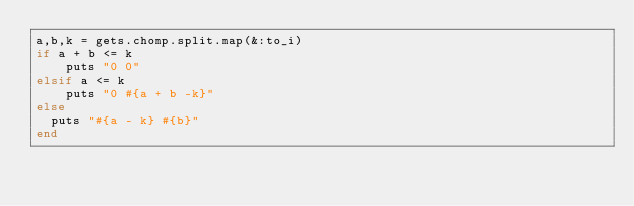Convert code to text. <code><loc_0><loc_0><loc_500><loc_500><_Ruby_>a,b,k = gets.chomp.split.map(&:to_i)
if a + b <= k
    puts "0 0"
elsif a <= k
    puts "0 #{a + b -k}"
else
  puts "#{a - k} #{b}"
end</code> 